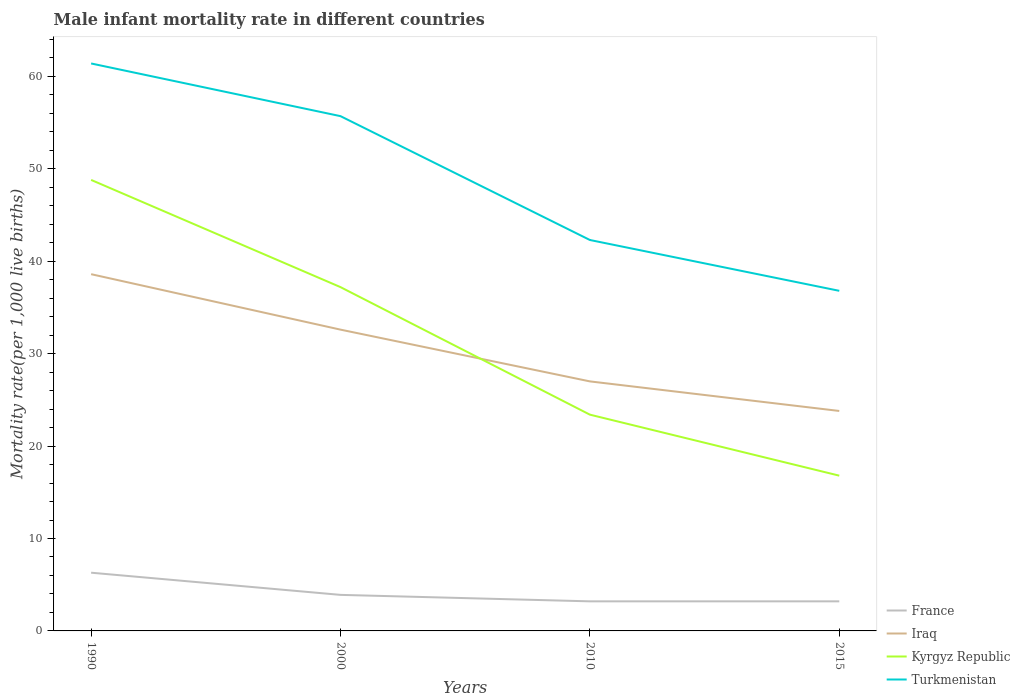Is the number of lines equal to the number of legend labels?
Your answer should be compact. Yes. In which year was the male infant mortality rate in France maximum?
Make the answer very short. 2010. What is the total male infant mortality rate in France in the graph?
Your answer should be compact. 0.7. What is the difference between the highest and the second highest male infant mortality rate in Iraq?
Your answer should be compact. 14.8. What is the difference between the highest and the lowest male infant mortality rate in Turkmenistan?
Your answer should be compact. 2. Is the male infant mortality rate in Turkmenistan strictly greater than the male infant mortality rate in Iraq over the years?
Ensure brevity in your answer.  No. How many lines are there?
Your answer should be compact. 4. Where does the legend appear in the graph?
Ensure brevity in your answer.  Bottom right. How are the legend labels stacked?
Offer a terse response. Vertical. What is the title of the graph?
Your answer should be very brief. Male infant mortality rate in different countries. What is the label or title of the X-axis?
Provide a succinct answer. Years. What is the label or title of the Y-axis?
Offer a very short reply. Mortality rate(per 1,0 live births). What is the Mortality rate(per 1,000 live births) of Iraq in 1990?
Your response must be concise. 38.6. What is the Mortality rate(per 1,000 live births) of Kyrgyz Republic in 1990?
Give a very brief answer. 48.8. What is the Mortality rate(per 1,000 live births) in Turkmenistan in 1990?
Your answer should be very brief. 61.4. What is the Mortality rate(per 1,000 live births) of Iraq in 2000?
Offer a very short reply. 32.6. What is the Mortality rate(per 1,000 live births) in Kyrgyz Republic in 2000?
Your answer should be very brief. 37.2. What is the Mortality rate(per 1,000 live births) of Turkmenistan in 2000?
Your answer should be very brief. 55.7. What is the Mortality rate(per 1,000 live births) in Iraq in 2010?
Keep it short and to the point. 27. What is the Mortality rate(per 1,000 live births) in Kyrgyz Republic in 2010?
Offer a very short reply. 23.4. What is the Mortality rate(per 1,000 live births) in Turkmenistan in 2010?
Keep it short and to the point. 42.3. What is the Mortality rate(per 1,000 live births) in Iraq in 2015?
Offer a very short reply. 23.8. What is the Mortality rate(per 1,000 live births) of Turkmenistan in 2015?
Offer a very short reply. 36.8. Across all years, what is the maximum Mortality rate(per 1,000 live births) of France?
Provide a short and direct response. 6.3. Across all years, what is the maximum Mortality rate(per 1,000 live births) in Iraq?
Your answer should be compact. 38.6. Across all years, what is the maximum Mortality rate(per 1,000 live births) in Kyrgyz Republic?
Make the answer very short. 48.8. Across all years, what is the maximum Mortality rate(per 1,000 live births) of Turkmenistan?
Offer a terse response. 61.4. Across all years, what is the minimum Mortality rate(per 1,000 live births) in Iraq?
Offer a very short reply. 23.8. Across all years, what is the minimum Mortality rate(per 1,000 live births) of Turkmenistan?
Give a very brief answer. 36.8. What is the total Mortality rate(per 1,000 live births) in Iraq in the graph?
Your response must be concise. 122. What is the total Mortality rate(per 1,000 live births) in Kyrgyz Republic in the graph?
Your answer should be very brief. 126.2. What is the total Mortality rate(per 1,000 live births) in Turkmenistan in the graph?
Provide a succinct answer. 196.2. What is the difference between the Mortality rate(per 1,000 live births) in France in 1990 and that in 2000?
Give a very brief answer. 2.4. What is the difference between the Mortality rate(per 1,000 live births) in Iraq in 1990 and that in 2000?
Ensure brevity in your answer.  6. What is the difference between the Mortality rate(per 1,000 live births) of Turkmenistan in 1990 and that in 2000?
Make the answer very short. 5.7. What is the difference between the Mortality rate(per 1,000 live births) in France in 1990 and that in 2010?
Your response must be concise. 3.1. What is the difference between the Mortality rate(per 1,000 live births) in Iraq in 1990 and that in 2010?
Make the answer very short. 11.6. What is the difference between the Mortality rate(per 1,000 live births) in Kyrgyz Republic in 1990 and that in 2010?
Offer a terse response. 25.4. What is the difference between the Mortality rate(per 1,000 live births) of France in 1990 and that in 2015?
Your answer should be compact. 3.1. What is the difference between the Mortality rate(per 1,000 live births) of Iraq in 1990 and that in 2015?
Offer a terse response. 14.8. What is the difference between the Mortality rate(per 1,000 live births) of Turkmenistan in 1990 and that in 2015?
Offer a very short reply. 24.6. What is the difference between the Mortality rate(per 1,000 live births) of France in 2000 and that in 2010?
Offer a terse response. 0.7. What is the difference between the Mortality rate(per 1,000 live births) in Turkmenistan in 2000 and that in 2010?
Make the answer very short. 13.4. What is the difference between the Mortality rate(per 1,000 live births) of Iraq in 2000 and that in 2015?
Your answer should be compact. 8.8. What is the difference between the Mortality rate(per 1,000 live births) of Kyrgyz Republic in 2000 and that in 2015?
Make the answer very short. 20.4. What is the difference between the Mortality rate(per 1,000 live births) of Turkmenistan in 2000 and that in 2015?
Keep it short and to the point. 18.9. What is the difference between the Mortality rate(per 1,000 live births) of Iraq in 2010 and that in 2015?
Your response must be concise. 3.2. What is the difference between the Mortality rate(per 1,000 live births) in Kyrgyz Republic in 2010 and that in 2015?
Ensure brevity in your answer.  6.6. What is the difference between the Mortality rate(per 1,000 live births) of Turkmenistan in 2010 and that in 2015?
Provide a succinct answer. 5.5. What is the difference between the Mortality rate(per 1,000 live births) of France in 1990 and the Mortality rate(per 1,000 live births) of Iraq in 2000?
Make the answer very short. -26.3. What is the difference between the Mortality rate(per 1,000 live births) in France in 1990 and the Mortality rate(per 1,000 live births) in Kyrgyz Republic in 2000?
Make the answer very short. -30.9. What is the difference between the Mortality rate(per 1,000 live births) in France in 1990 and the Mortality rate(per 1,000 live births) in Turkmenistan in 2000?
Provide a short and direct response. -49.4. What is the difference between the Mortality rate(per 1,000 live births) in Iraq in 1990 and the Mortality rate(per 1,000 live births) in Turkmenistan in 2000?
Ensure brevity in your answer.  -17.1. What is the difference between the Mortality rate(per 1,000 live births) of Kyrgyz Republic in 1990 and the Mortality rate(per 1,000 live births) of Turkmenistan in 2000?
Your answer should be compact. -6.9. What is the difference between the Mortality rate(per 1,000 live births) in France in 1990 and the Mortality rate(per 1,000 live births) in Iraq in 2010?
Offer a terse response. -20.7. What is the difference between the Mortality rate(per 1,000 live births) of France in 1990 and the Mortality rate(per 1,000 live births) of Kyrgyz Republic in 2010?
Keep it short and to the point. -17.1. What is the difference between the Mortality rate(per 1,000 live births) of France in 1990 and the Mortality rate(per 1,000 live births) of Turkmenistan in 2010?
Provide a short and direct response. -36. What is the difference between the Mortality rate(per 1,000 live births) in Iraq in 1990 and the Mortality rate(per 1,000 live births) in Kyrgyz Republic in 2010?
Your answer should be very brief. 15.2. What is the difference between the Mortality rate(per 1,000 live births) in France in 1990 and the Mortality rate(per 1,000 live births) in Iraq in 2015?
Ensure brevity in your answer.  -17.5. What is the difference between the Mortality rate(per 1,000 live births) in France in 1990 and the Mortality rate(per 1,000 live births) in Turkmenistan in 2015?
Give a very brief answer. -30.5. What is the difference between the Mortality rate(per 1,000 live births) in Iraq in 1990 and the Mortality rate(per 1,000 live births) in Kyrgyz Republic in 2015?
Make the answer very short. 21.8. What is the difference between the Mortality rate(per 1,000 live births) of Iraq in 1990 and the Mortality rate(per 1,000 live births) of Turkmenistan in 2015?
Make the answer very short. 1.8. What is the difference between the Mortality rate(per 1,000 live births) of France in 2000 and the Mortality rate(per 1,000 live births) of Iraq in 2010?
Your answer should be very brief. -23.1. What is the difference between the Mortality rate(per 1,000 live births) in France in 2000 and the Mortality rate(per 1,000 live births) in Kyrgyz Republic in 2010?
Give a very brief answer. -19.5. What is the difference between the Mortality rate(per 1,000 live births) of France in 2000 and the Mortality rate(per 1,000 live births) of Turkmenistan in 2010?
Make the answer very short. -38.4. What is the difference between the Mortality rate(per 1,000 live births) in Iraq in 2000 and the Mortality rate(per 1,000 live births) in Turkmenistan in 2010?
Give a very brief answer. -9.7. What is the difference between the Mortality rate(per 1,000 live births) in Kyrgyz Republic in 2000 and the Mortality rate(per 1,000 live births) in Turkmenistan in 2010?
Offer a very short reply. -5.1. What is the difference between the Mortality rate(per 1,000 live births) of France in 2000 and the Mortality rate(per 1,000 live births) of Iraq in 2015?
Offer a terse response. -19.9. What is the difference between the Mortality rate(per 1,000 live births) of France in 2000 and the Mortality rate(per 1,000 live births) of Turkmenistan in 2015?
Your response must be concise. -32.9. What is the difference between the Mortality rate(per 1,000 live births) in Iraq in 2000 and the Mortality rate(per 1,000 live births) in Turkmenistan in 2015?
Your answer should be very brief. -4.2. What is the difference between the Mortality rate(per 1,000 live births) of France in 2010 and the Mortality rate(per 1,000 live births) of Iraq in 2015?
Make the answer very short. -20.6. What is the difference between the Mortality rate(per 1,000 live births) of France in 2010 and the Mortality rate(per 1,000 live births) of Kyrgyz Republic in 2015?
Ensure brevity in your answer.  -13.6. What is the difference between the Mortality rate(per 1,000 live births) in France in 2010 and the Mortality rate(per 1,000 live births) in Turkmenistan in 2015?
Your answer should be compact. -33.6. What is the difference between the Mortality rate(per 1,000 live births) of Iraq in 2010 and the Mortality rate(per 1,000 live births) of Kyrgyz Republic in 2015?
Offer a very short reply. 10.2. What is the difference between the Mortality rate(per 1,000 live births) in Iraq in 2010 and the Mortality rate(per 1,000 live births) in Turkmenistan in 2015?
Keep it short and to the point. -9.8. What is the difference between the Mortality rate(per 1,000 live births) of Kyrgyz Republic in 2010 and the Mortality rate(per 1,000 live births) of Turkmenistan in 2015?
Provide a succinct answer. -13.4. What is the average Mortality rate(per 1,000 live births) of France per year?
Your answer should be compact. 4.15. What is the average Mortality rate(per 1,000 live births) of Iraq per year?
Your response must be concise. 30.5. What is the average Mortality rate(per 1,000 live births) of Kyrgyz Republic per year?
Offer a terse response. 31.55. What is the average Mortality rate(per 1,000 live births) of Turkmenistan per year?
Give a very brief answer. 49.05. In the year 1990, what is the difference between the Mortality rate(per 1,000 live births) of France and Mortality rate(per 1,000 live births) of Iraq?
Provide a succinct answer. -32.3. In the year 1990, what is the difference between the Mortality rate(per 1,000 live births) in France and Mortality rate(per 1,000 live births) in Kyrgyz Republic?
Offer a very short reply. -42.5. In the year 1990, what is the difference between the Mortality rate(per 1,000 live births) of France and Mortality rate(per 1,000 live births) of Turkmenistan?
Your answer should be very brief. -55.1. In the year 1990, what is the difference between the Mortality rate(per 1,000 live births) in Iraq and Mortality rate(per 1,000 live births) in Turkmenistan?
Ensure brevity in your answer.  -22.8. In the year 2000, what is the difference between the Mortality rate(per 1,000 live births) in France and Mortality rate(per 1,000 live births) in Iraq?
Offer a very short reply. -28.7. In the year 2000, what is the difference between the Mortality rate(per 1,000 live births) of France and Mortality rate(per 1,000 live births) of Kyrgyz Republic?
Provide a succinct answer. -33.3. In the year 2000, what is the difference between the Mortality rate(per 1,000 live births) in France and Mortality rate(per 1,000 live births) in Turkmenistan?
Provide a succinct answer. -51.8. In the year 2000, what is the difference between the Mortality rate(per 1,000 live births) in Iraq and Mortality rate(per 1,000 live births) in Kyrgyz Republic?
Offer a terse response. -4.6. In the year 2000, what is the difference between the Mortality rate(per 1,000 live births) of Iraq and Mortality rate(per 1,000 live births) of Turkmenistan?
Give a very brief answer. -23.1. In the year 2000, what is the difference between the Mortality rate(per 1,000 live births) of Kyrgyz Republic and Mortality rate(per 1,000 live births) of Turkmenistan?
Your answer should be compact. -18.5. In the year 2010, what is the difference between the Mortality rate(per 1,000 live births) of France and Mortality rate(per 1,000 live births) of Iraq?
Offer a terse response. -23.8. In the year 2010, what is the difference between the Mortality rate(per 1,000 live births) of France and Mortality rate(per 1,000 live births) of Kyrgyz Republic?
Ensure brevity in your answer.  -20.2. In the year 2010, what is the difference between the Mortality rate(per 1,000 live births) in France and Mortality rate(per 1,000 live births) in Turkmenistan?
Your answer should be very brief. -39.1. In the year 2010, what is the difference between the Mortality rate(per 1,000 live births) of Iraq and Mortality rate(per 1,000 live births) of Turkmenistan?
Provide a succinct answer. -15.3. In the year 2010, what is the difference between the Mortality rate(per 1,000 live births) of Kyrgyz Republic and Mortality rate(per 1,000 live births) of Turkmenistan?
Give a very brief answer. -18.9. In the year 2015, what is the difference between the Mortality rate(per 1,000 live births) in France and Mortality rate(per 1,000 live births) in Iraq?
Give a very brief answer. -20.6. In the year 2015, what is the difference between the Mortality rate(per 1,000 live births) in France and Mortality rate(per 1,000 live births) in Kyrgyz Republic?
Keep it short and to the point. -13.6. In the year 2015, what is the difference between the Mortality rate(per 1,000 live births) in France and Mortality rate(per 1,000 live births) in Turkmenistan?
Make the answer very short. -33.6. In the year 2015, what is the difference between the Mortality rate(per 1,000 live births) of Iraq and Mortality rate(per 1,000 live births) of Turkmenistan?
Offer a very short reply. -13. What is the ratio of the Mortality rate(per 1,000 live births) in France in 1990 to that in 2000?
Provide a short and direct response. 1.62. What is the ratio of the Mortality rate(per 1,000 live births) in Iraq in 1990 to that in 2000?
Your answer should be very brief. 1.18. What is the ratio of the Mortality rate(per 1,000 live births) of Kyrgyz Republic in 1990 to that in 2000?
Your answer should be very brief. 1.31. What is the ratio of the Mortality rate(per 1,000 live births) in Turkmenistan in 1990 to that in 2000?
Offer a terse response. 1.1. What is the ratio of the Mortality rate(per 1,000 live births) in France in 1990 to that in 2010?
Provide a short and direct response. 1.97. What is the ratio of the Mortality rate(per 1,000 live births) of Iraq in 1990 to that in 2010?
Your answer should be compact. 1.43. What is the ratio of the Mortality rate(per 1,000 live births) of Kyrgyz Republic in 1990 to that in 2010?
Your answer should be compact. 2.09. What is the ratio of the Mortality rate(per 1,000 live births) of Turkmenistan in 1990 to that in 2010?
Keep it short and to the point. 1.45. What is the ratio of the Mortality rate(per 1,000 live births) in France in 1990 to that in 2015?
Provide a short and direct response. 1.97. What is the ratio of the Mortality rate(per 1,000 live births) in Iraq in 1990 to that in 2015?
Provide a short and direct response. 1.62. What is the ratio of the Mortality rate(per 1,000 live births) of Kyrgyz Republic in 1990 to that in 2015?
Offer a terse response. 2.9. What is the ratio of the Mortality rate(per 1,000 live births) in Turkmenistan in 1990 to that in 2015?
Provide a succinct answer. 1.67. What is the ratio of the Mortality rate(per 1,000 live births) in France in 2000 to that in 2010?
Your answer should be compact. 1.22. What is the ratio of the Mortality rate(per 1,000 live births) in Iraq in 2000 to that in 2010?
Give a very brief answer. 1.21. What is the ratio of the Mortality rate(per 1,000 live births) of Kyrgyz Republic in 2000 to that in 2010?
Ensure brevity in your answer.  1.59. What is the ratio of the Mortality rate(per 1,000 live births) of Turkmenistan in 2000 to that in 2010?
Ensure brevity in your answer.  1.32. What is the ratio of the Mortality rate(per 1,000 live births) of France in 2000 to that in 2015?
Make the answer very short. 1.22. What is the ratio of the Mortality rate(per 1,000 live births) in Iraq in 2000 to that in 2015?
Offer a terse response. 1.37. What is the ratio of the Mortality rate(per 1,000 live births) of Kyrgyz Republic in 2000 to that in 2015?
Your response must be concise. 2.21. What is the ratio of the Mortality rate(per 1,000 live births) of Turkmenistan in 2000 to that in 2015?
Your answer should be very brief. 1.51. What is the ratio of the Mortality rate(per 1,000 live births) of Iraq in 2010 to that in 2015?
Make the answer very short. 1.13. What is the ratio of the Mortality rate(per 1,000 live births) in Kyrgyz Republic in 2010 to that in 2015?
Your response must be concise. 1.39. What is the ratio of the Mortality rate(per 1,000 live births) in Turkmenistan in 2010 to that in 2015?
Your answer should be compact. 1.15. What is the difference between the highest and the second highest Mortality rate(per 1,000 live births) of Kyrgyz Republic?
Give a very brief answer. 11.6. What is the difference between the highest and the second highest Mortality rate(per 1,000 live births) in Turkmenistan?
Make the answer very short. 5.7. What is the difference between the highest and the lowest Mortality rate(per 1,000 live births) of Kyrgyz Republic?
Your answer should be very brief. 32. What is the difference between the highest and the lowest Mortality rate(per 1,000 live births) in Turkmenistan?
Ensure brevity in your answer.  24.6. 